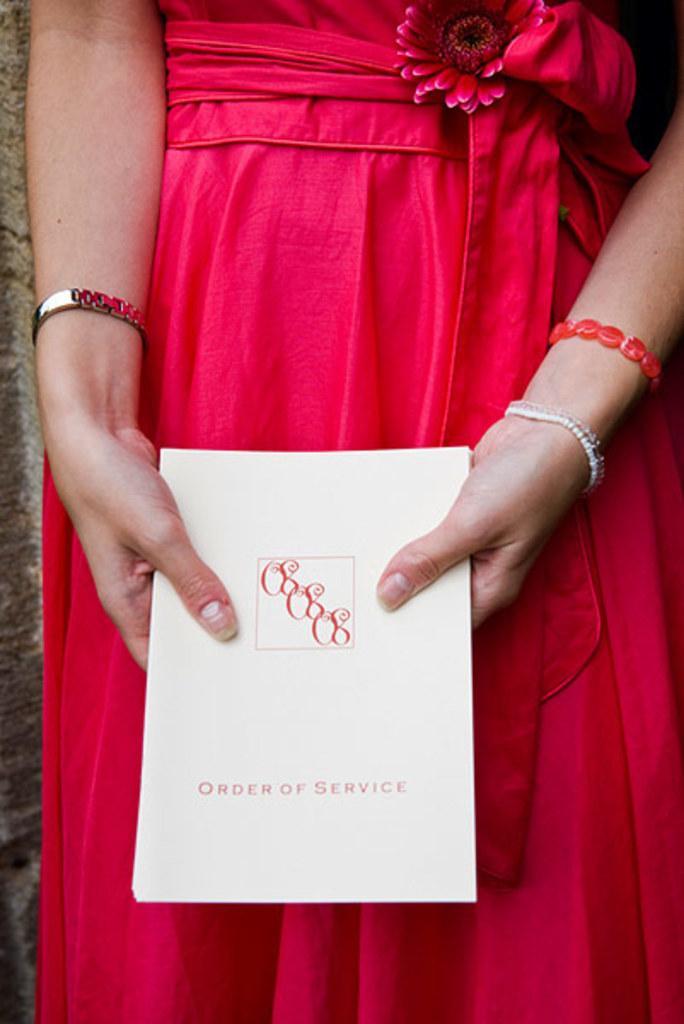In one or two sentences, can you explain what this image depicts? In this picture we can see the lower part of the body of a person in pink dress holding a card with some text on it. We can see a pink flower, watch and bracelet. 